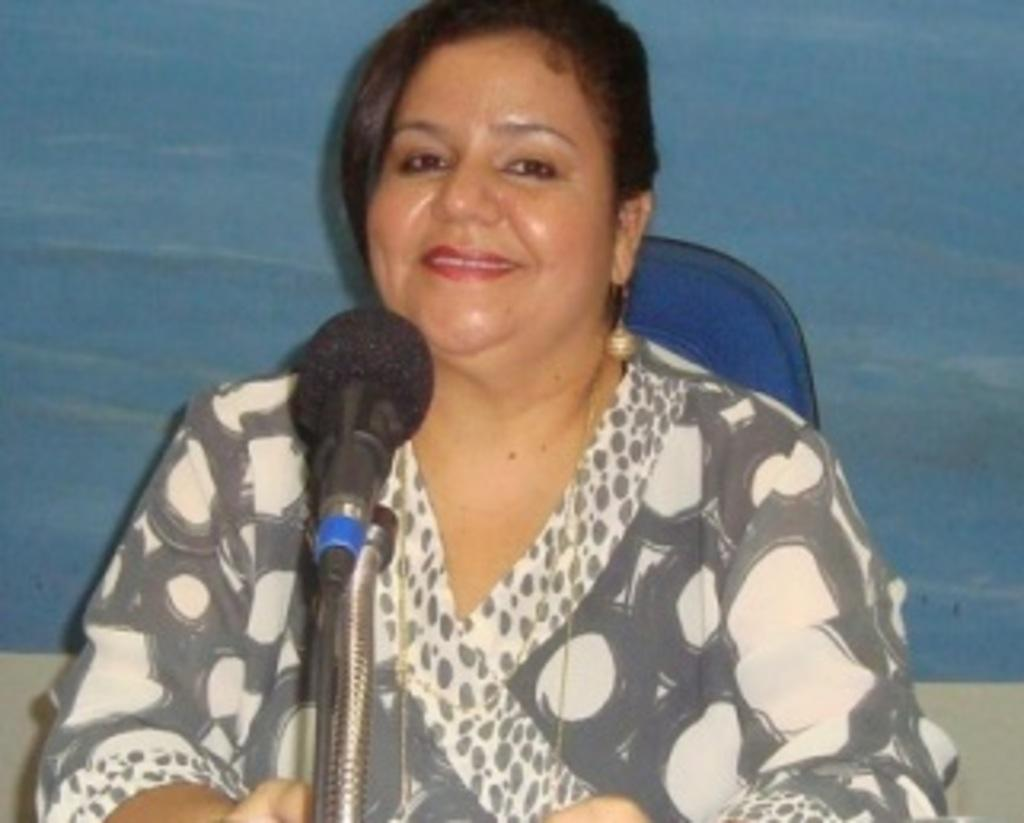What is the main subject of the image? The main subject of the image is a woman. What is the woman doing in the image? The woman is smiling in the image. What object is in front of the woman? There is a microphone in front of the woman. What type of fuel is being used by the woman in the image? There is no indication in the image that the woman is using any type of fuel, as she is simply smiling with a microphone in front of her. 